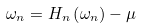<formula> <loc_0><loc_0><loc_500><loc_500>\omega _ { n } = H _ { n } \left ( \omega _ { n } \right ) - \mu</formula> 